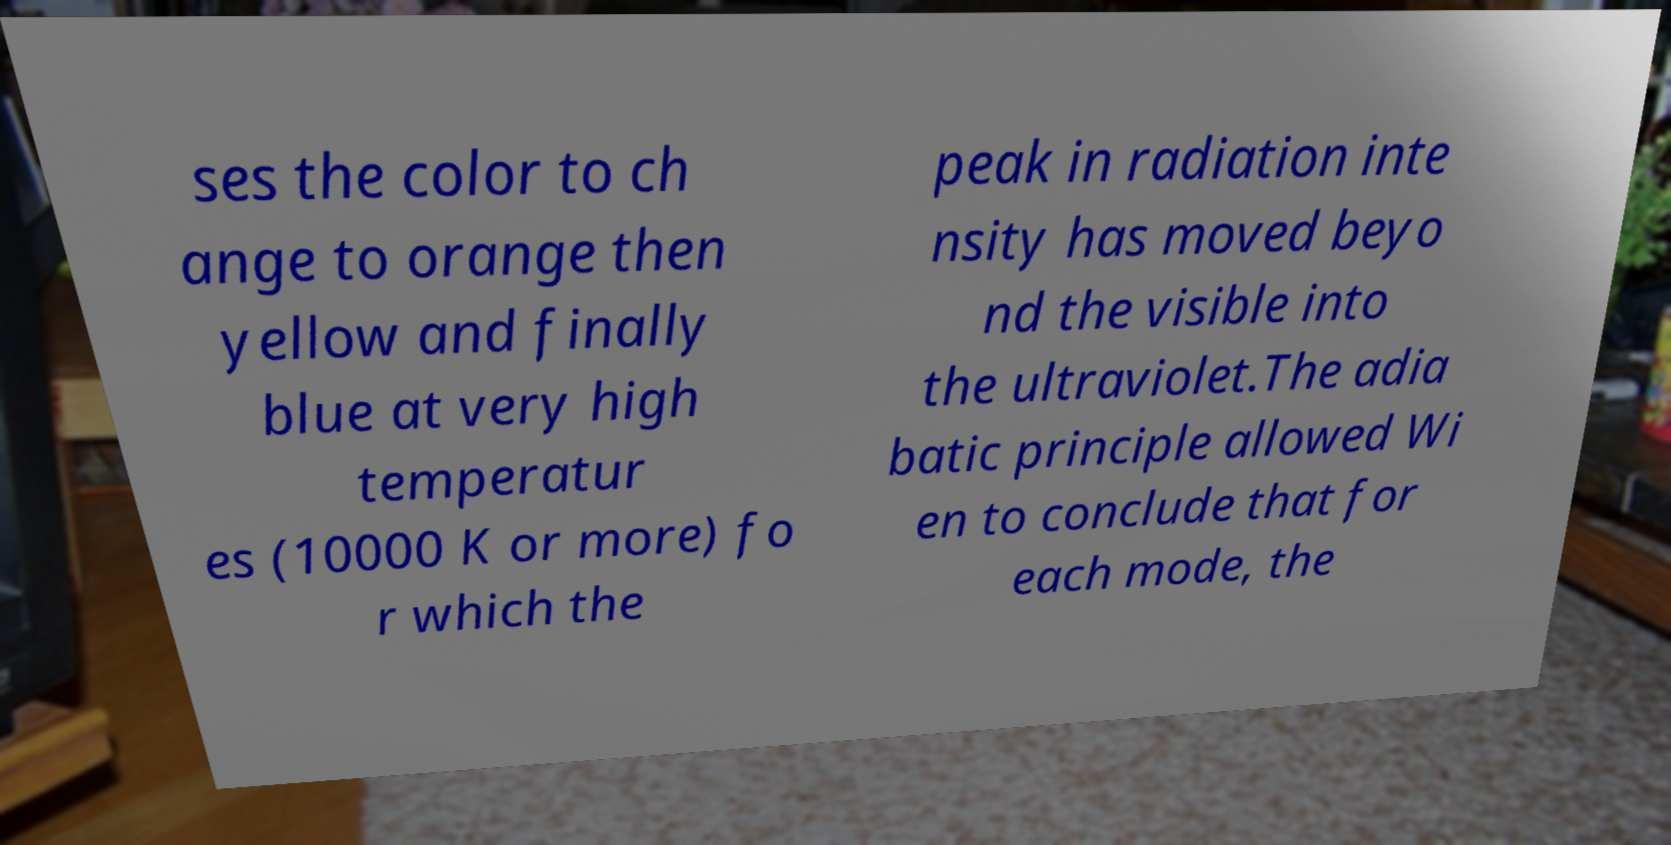Please read and relay the text visible in this image. What does it say? ses the color to ch ange to orange then yellow and finally blue at very high temperatur es (10000 K or more) fo r which the peak in radiation inte nsity has moved beyo nd the visible into the ultraviolet.The adia batic principle allowed Wi en to conclude that for each mode, the 